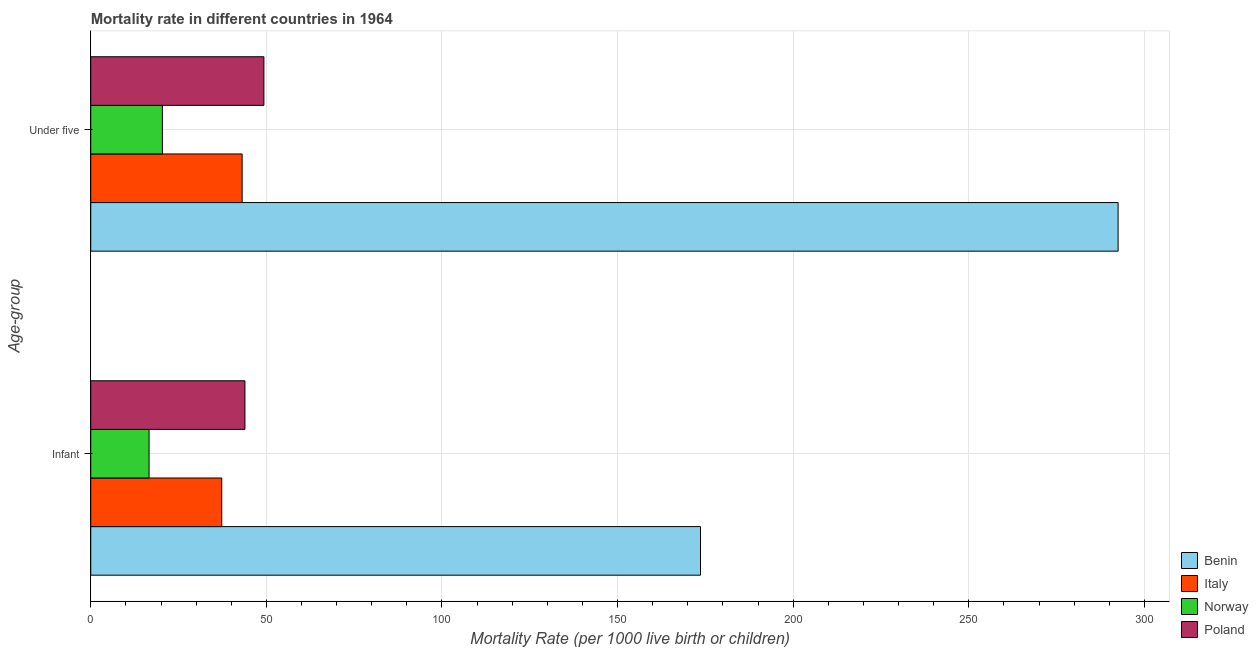How many groups of bars are there?
Ensure brevity in your answer.  2. Are the number of bars on each tick of the Y-axis equal?
Give a very brief answer. Yes. How many bars are there on the 1st tick from the top?
Keep it short and to the point. 4. What is the label of the 1st group of bars from the top?
Give a very brief answer. Under five. What is the infant mortality rate in Norway?
Offer a very short reply. 16.6. Across all countries, what is the maximum infant mortality rate?
Offer a terse response. 173.6. Across all countries, what is the minimum under-5 mortality rate?
Offer a terse response. 20.4. In which country was the under-5 mortality rate maximum?
Provide a succinct answer. Benin. What is the total under-5 mortality rate in the graph?
Your response must be concise. 405.3. What is the difference between the infant mortality rate in Italy and that in Norway?
Offer a terse response. 20.7. What is the difference between the under-5 mortality rate in Italy and the infant mortality rate in Poland?
Provide a succinct answer. -0.8. What is the average infant mortality rate per country?
Offer a terse response. 67.85. What is the difference between the under-5 mortality rate and infant mortality rate in Poland?
Keep it short and to the point. 5.4. In how many countries, is the infant mortality rate greater than 110 ?
Provide a short and direct response. 1. What is the ratio of the infant mortality rate in Benin to that in Norway?
Your answer should be compact. 10.46. What does the 3rd bar from the top in Infant represents?
Provide a short and direct response. Italy. Are all the bars in the graph horizontal?
Provide a succinct answer. Yes. Does the graph contain any zero values?
Your answer should be very brief. No. Where does the legend appear in the graph?
Give a very brief answer. Bottom right. How are the legend labels stacked?
Your answer should be very brief. Vertical. What is the title of the graph?
Your answer should be compact. Mortality rate in different countries in 1964. Does "Euro area" appear as one of the legend labels in the graph?
Offer a very short reply. No. What is the label or title of the X-axis?
Your answer should be very brief. Mortality Rate (per 1000 live birth or children). What is the label or title of the Y-axis?
Offer a terse response. Age-group. What is the Mortality Rate (per 1000 live birth or children) in Benin in Infant?
Give a very brief answer. 173.6. What is the Mortality Rate (per 1000 live birth or children) of Italy in Infant?
Give a very brief answer. 37.3. What is the Mortality Rate (per 1000 live birth or children) of Norway in Infant?
Provide a succinct answer. 16.6. What is the Mortality Rate (per 1000 live birth or children) in Poland in Infant?
Your answer should be compact. 43.9. What is the Mortality Rate (per 1000 live birth or children) in Benin in Under five?
Provide a succinct answer. 292.5. What is the Mortality Rate (per 1000 live birth or children) in Italy in Under five?
Ensure brevity in your answer.  43.1. What is the Mortality Rate (per 1000 live birth or children) in Norway in Under five?
Provide a succinct answer. 20.4. What is the Mortality Rate (per 1000 live birth or children) of Poland in Under five?
Your response must be concise. 49.3. Across all Age-group, what is the maximum Mortality Rate (per 1000 live birth or children) in Benin?
Your answer should be compact. 292.5. Across all Age-group, what is the maximum Mortality Rate (per 1000 live birth or children) of Italy?
Provide a short and direct response. 43.1. Across all Age-group, what is the maximum Mortality Rate (per 1000 live birth or children) of Norway?
Offer a very short reply. 20.4. Across all Age-group, what is the maximum Mortality Rate (per 1000 live birth or children) in Poland?
Your response must be concise. 49.3. Across all Age-group, what is the minimum Mortality Rate (per 1000 live birth or children) of Benin?
Your answer should be compact. 173.6. Across all Age-group, what is the minimum Mortality Rate (per 1000 live birth or children) in Italy?
Ensure brevity in your answer.  37.3. Across all Age-group, what is the minimum Mortality Rate (per 1000 live birth or children) in Norway?
Provide a short and direct response. 16.6. Across all Age-group, what is the minimum Mortality Rate (per 1000 live birth or children) of Poland?
Your response must be concise. 43.9. What is the total Mortality Rate (per 1000 live birth or children) in Benin in the graph?
Your answer should be compact. 466.1. What is the total Mortality Rate (per 1000 live birth or children) in Italy in the graph?
Your response must be concise. 80.4. What is the total Mortality Rate (per 1000 live birth or children) in Poland in the graph?
Offer a very short reply. 93.2. What is the difference between the Mortality Rate (per 1000 live birth or children) in Benin in Infant and that in Under five?
Provide a short and direct response. -118.9. What is the difference between the Mortality Rate (per 1000 live birth or children) of Italy in Infant and that in Under five?
Provide a short and direct response. -5.8. What is the difference between the Mortality Rate (per 1000 live birth or children) of Norway in Infant and that in Under five?
Offer a very short reply. -3.8. What is the difference between the Mortality Rate (per 1000 live birth or children) of Poland in Infant and that in Under five?
Provide a succinct answer. -5.4. What is the difference between the Mortality Rate (per 1000 live birth or children) of Benin in Infant and the Mortality Rate (per 1000 live birth or children) of Italy in Under five?
Your answer should be very brief. 130.5. What is the difference between the Mortality Rate (per 1000 live birth or children) in Benin in Infant and the Mortality Rate (per 1000 live birth or children) in Norway in Under five?
Make the answer very short. 153.2. What is the difference between the Mortality Rate (per 1000 live birth or children) of Benin in Infant and the Mortality Rate (per 1000 live birth or children) of Poland in Under five?
Make the answer very short. 124.3. What is the difference between the Mortality Rate (per 1000 live birth or children) in Italy in Infant and the Mortality Rate (per 1000 live birth or children) in Norway in Under five?
Your response must be concise. 16.9. What is the difference between the Mortality Rate (per 1000 live birth or children) in Italy in Infant and the Mortality Rate (per 1000 live birth or children) in Poland in Under five?
Give a very brief answer. -12. What is the difference between the Mortality Rate (per 1000 live birth or children) in Norway in Infant and the Mortality Rate (per 1000 live birth or children) in Poland in Under five?
Your answer should be compact. -32.7. What is the average Mortality Rate (per 1000 live birth or children) of Benin per Age-group?
Your response must be concise. 233.05. What is the average Mortality Rate (per 1000 live birth or children) of Italy per Age-group?
Offer a very short reply. 40.2. What is the average Mortality Rate (per 1000 live birth or children) of Poland per Age-group?
Provide a short and direct response. 46.6. What is the difference between the Mortality Rate (per 1000 live birth or children) of Benin and Mortality Rate (per 1000 live birth or children) of Italy in Infant?
Provide a short and direct response. 136.3. What is the difference between the Mortality Rate (per 1000 live birth or children) of Benin and Mortality Rate (per 1000 live birth or children) of Norway in Infant?
Offer a terse response. 157. What is the difference between the Mortality Rate (per 1000 live birth or children) of Benin and Mortality Rate (per 1000 live birth or children) of Poland in Infant?
Keep it short and to the point. 129.7. What is the difference between the Mortality Rate (per 1000 live birth or children) in Italy and Mortality Rate (per 1000 live birth or children) in Norway in Infant?
Your answer should be very brief. 20.7. What is the difference between the Mortality Rate (per 1000 live birth or children) in Italy and Mortality Rate (per 1000 live birth or children) in Poland in Infant?
Offer a terse response. -6.6. What is the difference between the Mortality Rate (per 1000 live birth or children) of Norway and Mortality Rate (per 1000 live birth or children) of Poland in Infant?
Offer a very short reply. -27.3. What is the difference between the Mortality Rate (per 1000 live birth or children) of Benin and Mortality Rate (per 1000 live birth or children) of Italy in Under five?
Keep it short and to the point. 249.4. What is the difference between the Mortality Rate (per 1000 live birth or children) in Benin and Mortality Rate (per 1000 live birth or children) in Norway in Under five?
Keep it short and to the point. 272.1. What is the difference between the Mortality Rate (per 1000 live birth or children) in Benin and Mortality Rate (per 1000 live birth or children) in Poland in Under five?
Keep it short and to the point. 243.2. What is the difference between the Mortality Rate (per 1000 live birth or children) in Italy and Mortality Rate (per 1000 live birth or children) in Norway in Under five?
Ensure brevity in your answer.  22.7. What is the difference between the Mortality Rate (per 1000 live birth or children) of Norway and Mortality Rate (per 1000 live birth or children) of Poland in Under five?
Give a very brief answer. -28.9. What is the ratio of the Mortality Rate (per 1000 live birth or children) in Benin in Infant to that in Under five?
Provide a short and direct response. 0.59. What is the ratio of the Mortality Rate (per 1000 live birth or children) of Italy in Infant to that in Under five?
Provide a short and direct response. 0.87. What is the ratio of the Mortality Rate (per 1000 live birth or children) of Norway in Infant to that in Under five?
Your answer should be very brief. 0.81. What is the ratio of the Mortality Rate (per 1000 live birth or children) in Poland in Infant to that in Under five?
Provide a succinct answer. 0.89. What is the difference between the highest and the second highest Mortality Rate (per 1000 live birth or children) in Benin?
Give a very brief answer. 118.9. What is the difference between the highest and the second highest Mortality Rate (per 1000 live birth or children) of Norway?
Give a very brief answer. 3.8. What is the difference between the highest and the second highest Mortality Rate (per 1000 live birth or children) of Poland?
Provide a short and direct response. 5.4. What is the difference between the highest and the lowest Mortality Rate (per 1000 live birth or children) in Benin?
Give a very brief answer. 118.9. What is the difference between the highest and the lowest Mortality Rate (per 1000 live birth or children) in Norway?
Provide a succinct answer. 3.8. What is the difference between the highest and the lowest Mortality Rate (per 1000 live birth or children) of Poland?
Your answer should be compact. 5.4. 